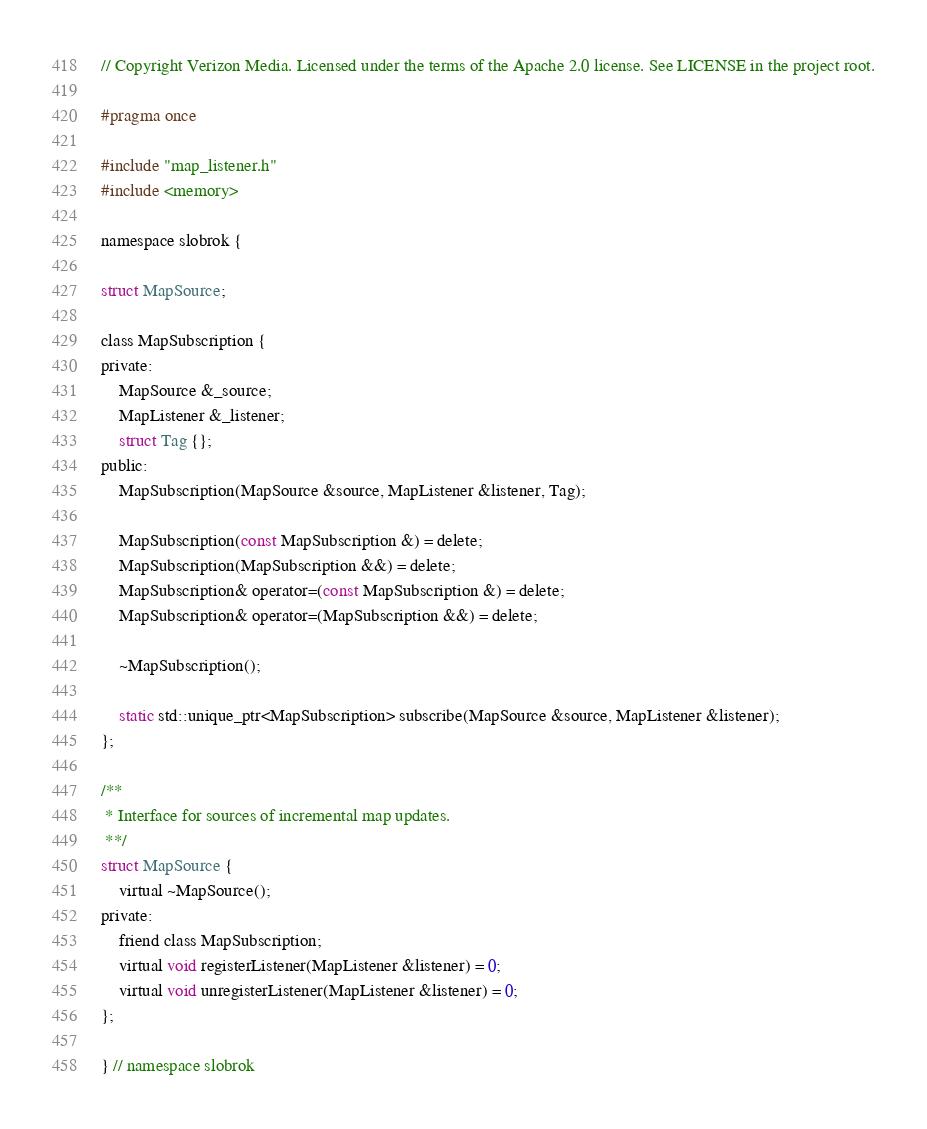Convert code to text. <code><loc_0><loc_0><loc_500><loc_500><_C_>// Copyright Verizon Media. Licensed under the terms of the Apache 2.0 license. See LICENSE in the project root.

#pragma once

#include "map_listener.h"
#include <memory>

namespace slobrok {

struct MapSource;

class MapSubscription {
private:
    MapSource &_source;
    MapListener &_listener;
    struct Tag {};
public:
    MapSubscription(MapSource &source, MapListener &listener, Tag);

    MapSubscription(const MapSubscription &) = delete;
    MapSubscription(MapSubscription &&) = delete;
    MapSubscription& operator=(const MapSubscription &) = delete;
    MapSubscription& operator=(MapSubscription &&) = delete;

    ~MapSubscription();

    static std::unique_ptr<MapSubscription> subscribe(MapSource &source, MapListener &listener);
};

/**
 * Interface for sources of incremental map updates.
 **/
struct MapSource {
    virtual ~MapSource();
private:
    friend class MapSubscription;
    virtual void registerListener(MapListener &listener) = 0;
    virtual void unregisterListener(MapListener &listener) = 0;
};

} // namespace slobrok

</code> 